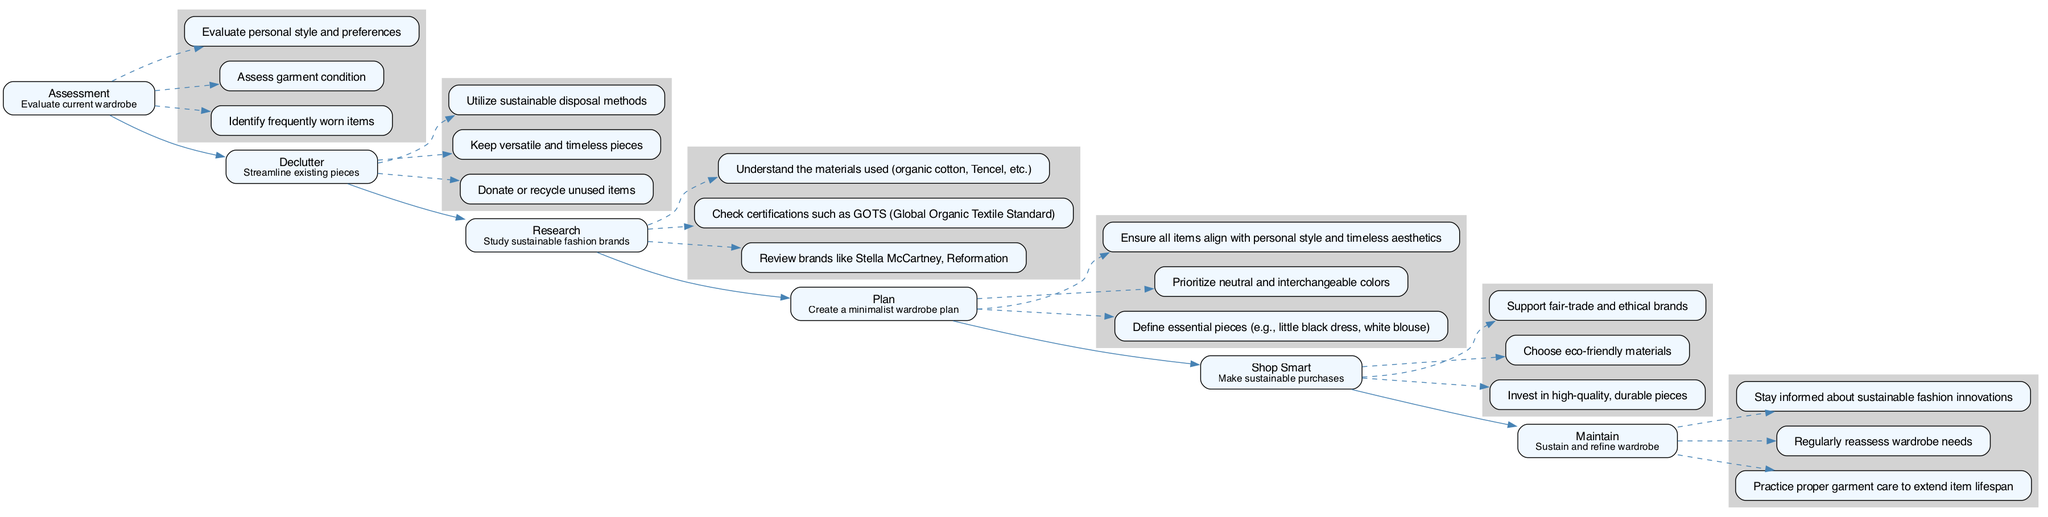What is the first step in the pathway? The first step in the pathway is "Assessment," which involves evaluating the current wardrobe.
Answer: Assessment How many actions are listed under the "Research" step? Under the "Research" step, there are three actions listed, which include reviewing brands, checking certifications, and understanding materials.
Answer: 3 Which step comes after "Declutter"? The step that comes after "Declutter" in the pathway is "Research."
Answer: Research What is the primary focus of the "Maintain" step? The primary focus of the "Maintain" step is to sustain and refine the wardrobe.
Answer: Sustain and refine wardrobe Which sustainable fashion brand is mentioned in the "Research" step? The sustainable fashion brand mentioned in the "Research" step is Stella McCartney.
Answer: Stella McCartney What type of care is emphasized in the "Maintain" step? The "Maintain" step emphasizes practicing proper garment care to extend item lifespan.
Answer: Proper garment care How many total steps are there in the pathway? There are a total of six steps in the pathway: Assessment, Declutter, Research, Plan, Shop Smart, and Maintain.
Answer: 6 What is the action recommended in the "Shop Smart" step? The action recommended in the "Shop Smart" step is to invest in high-quality, durable pieces.
Answer: Invest in high-quality, durable pieces Which node connects "Declutter" to "Research"? The node "Declutter" connects to the node "Research" with a directed edge indicating the flow from one step to another.
Answer: Research 